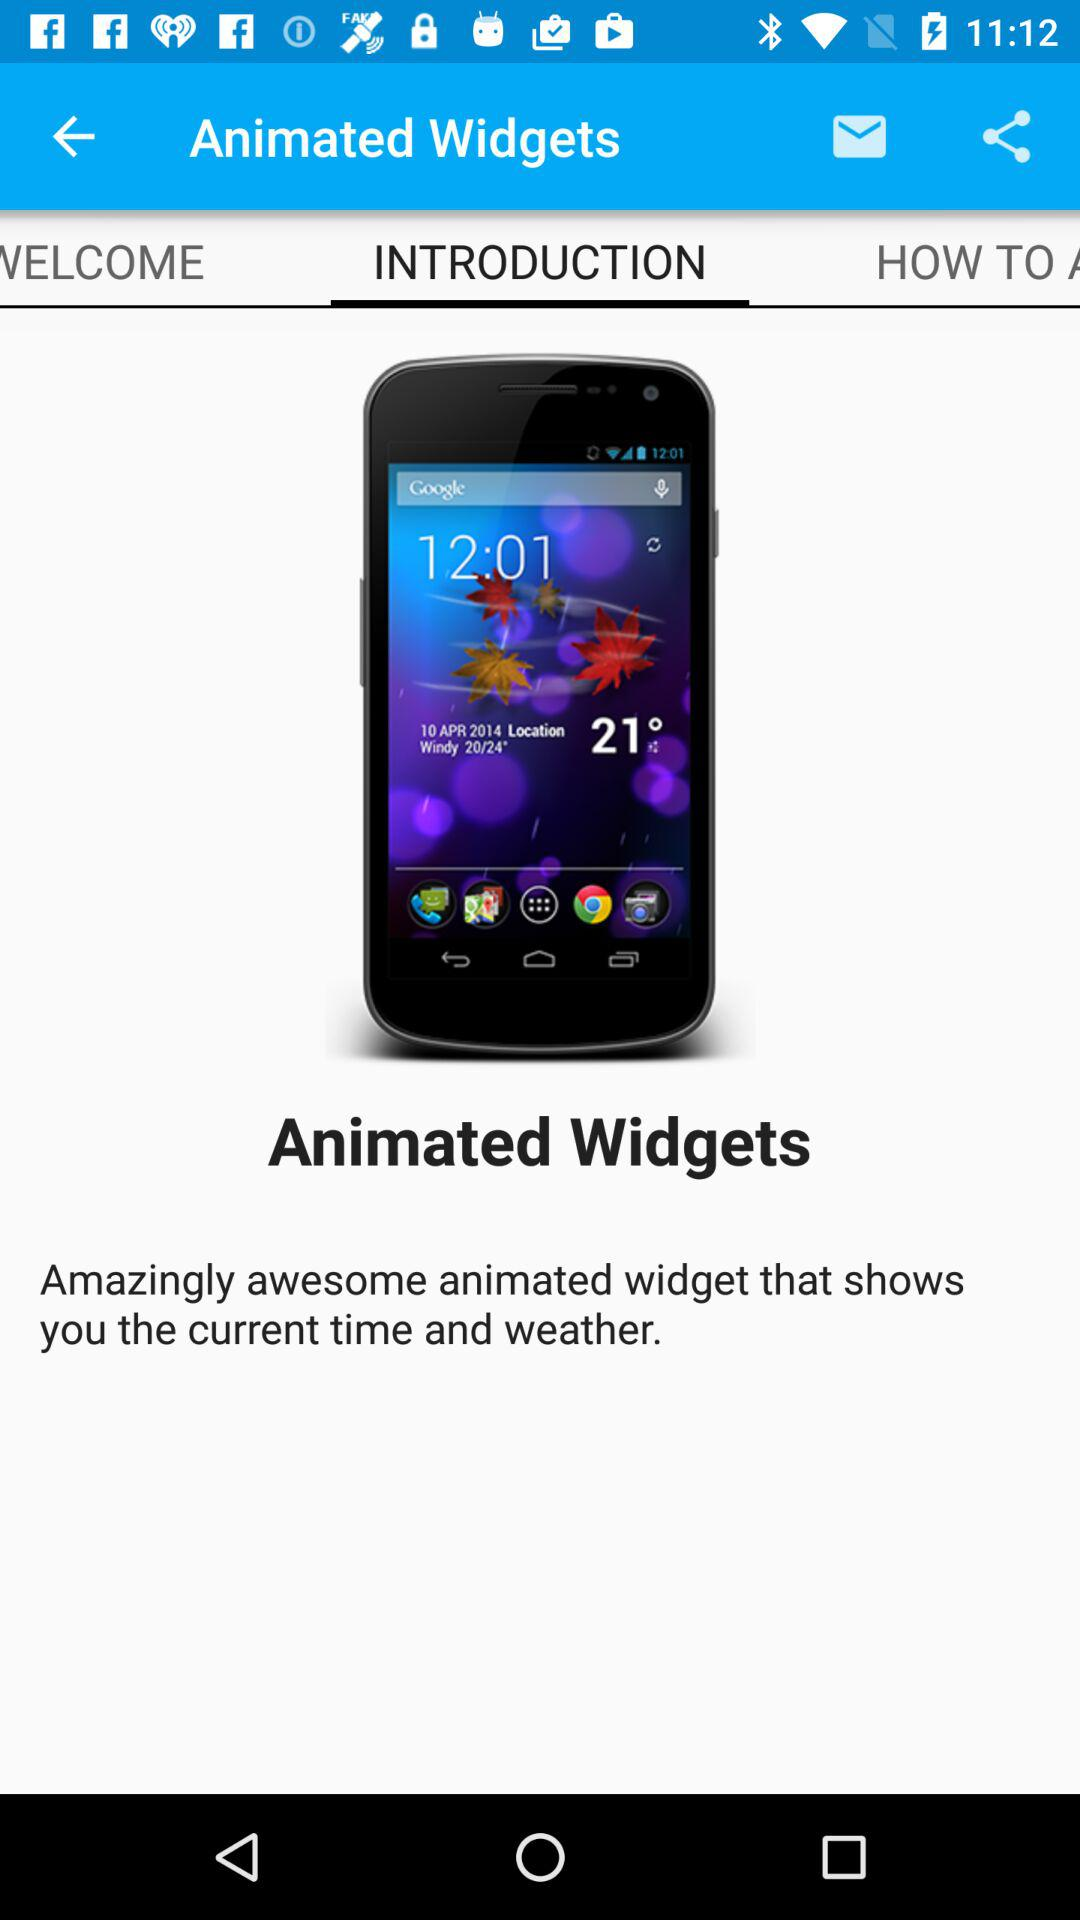Which option is selected? The selected option is "INTRODUCTION". 